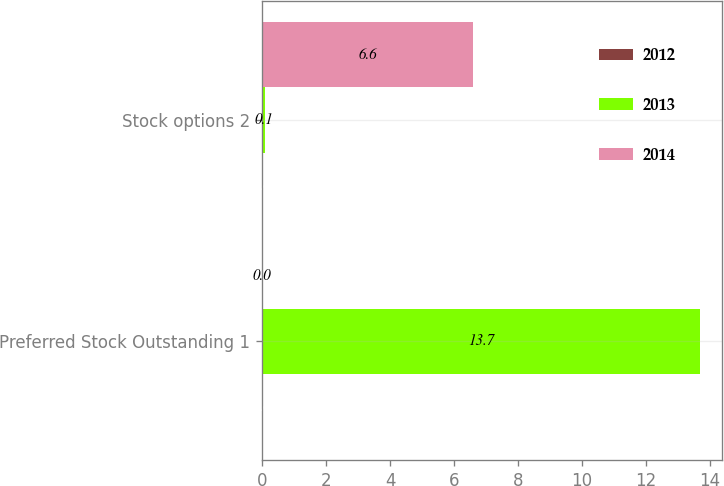Convert chart. <chart><loc_0><loc_0><loc_500><loc_500><stacked_bar_chart><ecel><fcel>Preferred Stock Outstanding 1<fcel>Stock options 2<nl><fcel>2012<fcel>0<fcel>0<nl><fcel>2013<fcel>13.7<fcel>0.1<nl><fcel>2014<fcel>0<fcel>6.6<nl></chart> 